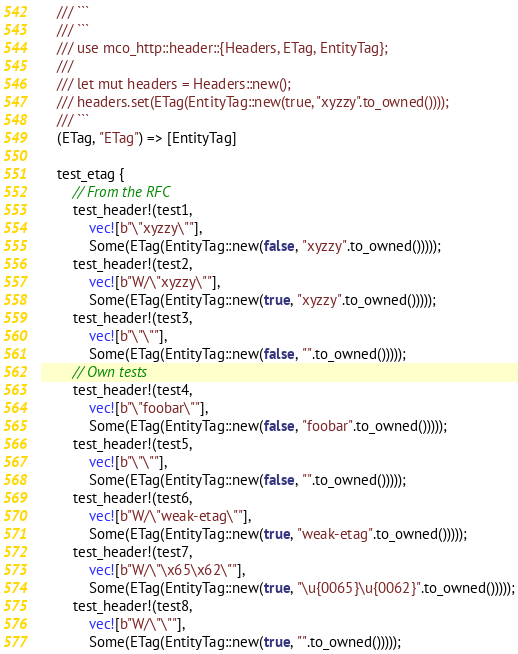Convert code to text. <code><loc_0><loc_0><loc_500><loc_500><_Rust_>    /// ```
    /// ```
    /// use mco_http::header::{Headers, ETag, EntityTag};
    ///
    /// let mut headers = Headers::new();
    /// headers.set(ETag(EntityTag::new(true, "xyzzy".to_owned())));
    /// ```
    (ETag, "ETag") => [EntityTag]

    test_etag {
        // From the RFC
        test_header!(test1,
            vec![b"\"xyzzy\""],
            Some(ETag(EntityTag::new(false, "xyzzy".to_owned()))));
        test_header!(test2,
            vec![b"W/\"xyzzy\""],
            Some(ETag(EntityTag::new(true, "xyzzy".to_owned()))));
        test_header!(test3,
            vec![b"\"\""],
            Some(ETag(EntityTag::new(false, "".to_owned()))));
        // Own tests
        test_header!(test4,
            vec![b"\"foobar\""],
            Some(ETag(EntityTag::new(false, "foobar".to_owned()))));
        test_header!(test5,
            vec![b"\"\""],
            Some(ETag(EntityTag::new(false, "".to_owned()))));
        test_header!(test6,
            vec![b"W/\"weak-etag\""],
            Some(ETag(EntityTag::new(true, "weak-etag".to_owned()))));
        test_header!(test7,
            vec![b"W/\"\x65\x62\""],
            Some(ETag(EntityTag::new(true, "\u{0065}\u{0062}".to_owned()))));
        test_header!(test8,
            vec![b"W/\"\""],
            Some(ETag(EntityTag::new(true, "".to_owned()))));</code> 